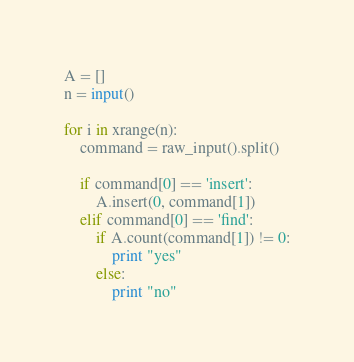Convert code to text. <code><loc_0><loc_0><loc_500><loc_500><_Python_>A = []
n = input()

for i in xrange(n):
    command = raw_input().split()

    if command[0] == 'insert':
        A.insert(0, command[1])
    elif command[0] == 'find':
        if A.count(command[1]) != 0:
            print "yes"
        else:
            print "no"</code> 